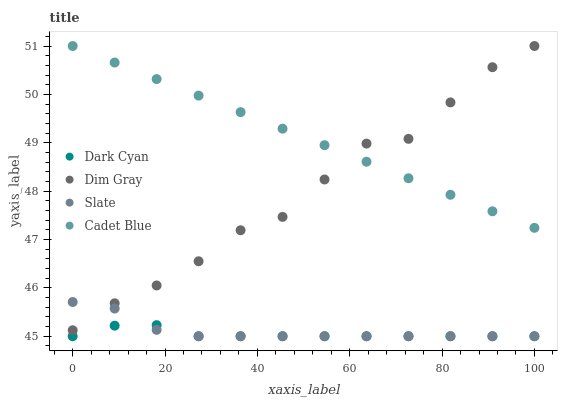Does Dark Cyan have the minimum area under the curve?
Answer yes or no. Yes. Does Cadet Blue have the maximum area under the curve?
Answer yes or no. Yes. Does Slate have the minimum area under the curve?
Answer yes or no. No. Does Slate have the maximum area under the curve?
Answer yes or no. No. Is Cadet Blue the smoothest?
Answer yes or no. Yes. Is Dim Gray the roughest?
Answer yes or no. Yes. Is Slate the smoothest?
Answer yes or no. No. Is Slate the roughest?
Answer yes or no. No. Does Dark Cyan have the lowest value?
Answer yes or no. Yes. Does Dim Gray have the lowest value?
Answer yes or no. No. Does Cadet Blue have the highest value?
Answer yes or no. Yes. Does Slate have the highest value?
Answer yes or no. No. Is Dark Cyan less than Cadet Blue?
Answer yes or no. Yes. Is Cadet Blue greater than Dark Cyan?
Answer yes or no. Yes. Does Dark Cyan intersect Slate?
Answer yes or no. Yes. Is Dark Cyan less than Slate?
Answer yes or no. No. Is Dark Cyan greater than Slate?
Answer yes or no. No. Does Dark Cyan intersect Cadet Blue?
Answer yes or no. No. 